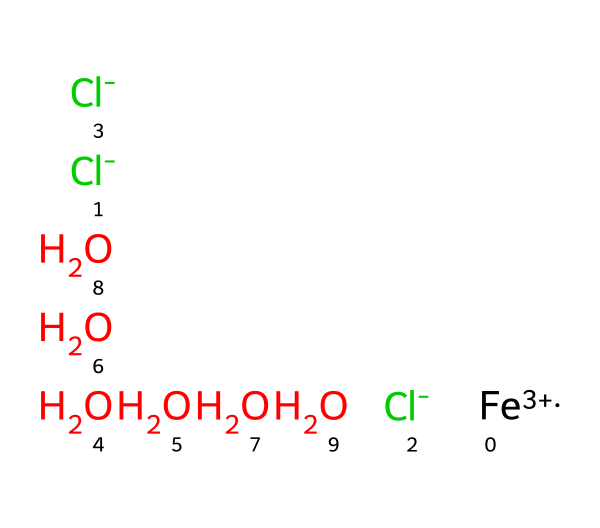What is the central metal atom in this compound? The central metal atom can be identified as iron using the SMILES representation, where [Fe+3] indicates the oxidation state of the iron.
Answer: iron How many chloride ions are present in this compound? In the SMILES representation, there are two instances of [Cl-], indicating that there are two chloride ions.
Answer: 2 What is the total number of water molecules in this compound? The SMILES representation shows six O atoms that are each followed by a water molecule indication (O.O.O.O.O.O), thus confirming there are six water molecules.
Answer: 6 What is the coordination number of iron in this complex? In coordination compounds, the coordination number is determined by the total number of ligands bonded to the metal. Here, there are 2 chloride ions and 6 water molecules, giving a total coordination number of 8.
Answer: 8 What type of compound is iron(III) chloride hexahydrate classified as? Given its composition and structure involving a central metal ion surrounded by ligands, it is classified as a coordination compound, specifically a metal salt with hydration.
Answer: coordination compound Why is this compound useful in wastewater treatment? Iron(III) chloride hexahydrate serves as a flocculant, promoting the aggregation of particles in wastewater which simplifies the removal processes, making it effective for treatment applications.
Answer: flocculant 